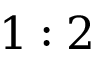Convert formula to latex. <formula><loc_0><loc_0><loc_500><loc_500>1 \colon 2</formula> 